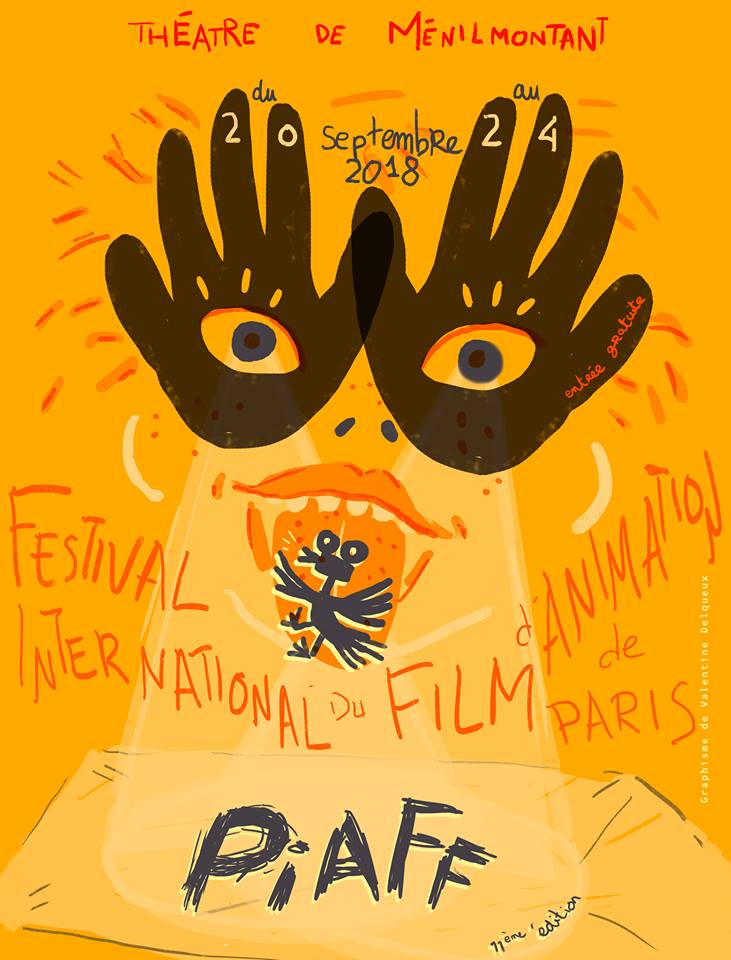Imagine the poster's world existed, how would the 'Festival International du Film d'Animation de Paris' look in that world? In a world where the poster's art comes to life, the 'Festival International du Film d'Animation de Paris' would be an enchanting, vibrant realm. The festival grounds would be animated in hues of orange and yellow, with every detail from the poster animated and alive. Attendees would enter through gates formed by the large, welcoming hands painted with eyes, greeting visitors with playful gestures. The venue itself, featuring numerous screens and stages, would be surrounded by lively, hand-drawn characters and whimsical creatures, freely mingling with guests. Vivid animations would light up the space, with letters from 'P·A·F' dancing in the air, guiding people to different events. The atmosphere would be one of joyful creativity, where the boundaries between art and reality blur, making every moment of the festival an immersive experience filled with wonder and delight. 